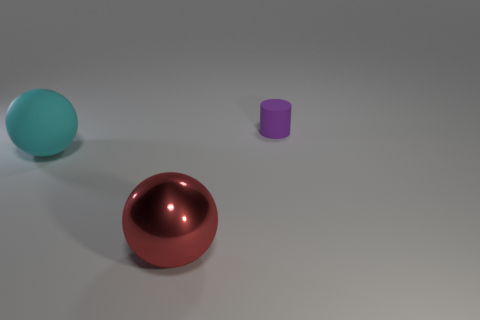Add 2 large metal things. How many objects exist? 5 Subtract all cylinders. How many objects are left? 2 Subtract 0 cyan cubes. How many objects are left? 3 Subtract all small purple things. Subtract all purple cylinders. How many objects are left? 1 Add 1 large metal spheres. How many large metal spheres are left? 2 Add 3 large red shiny cubes. How many large red shiny cubes exist? 3 